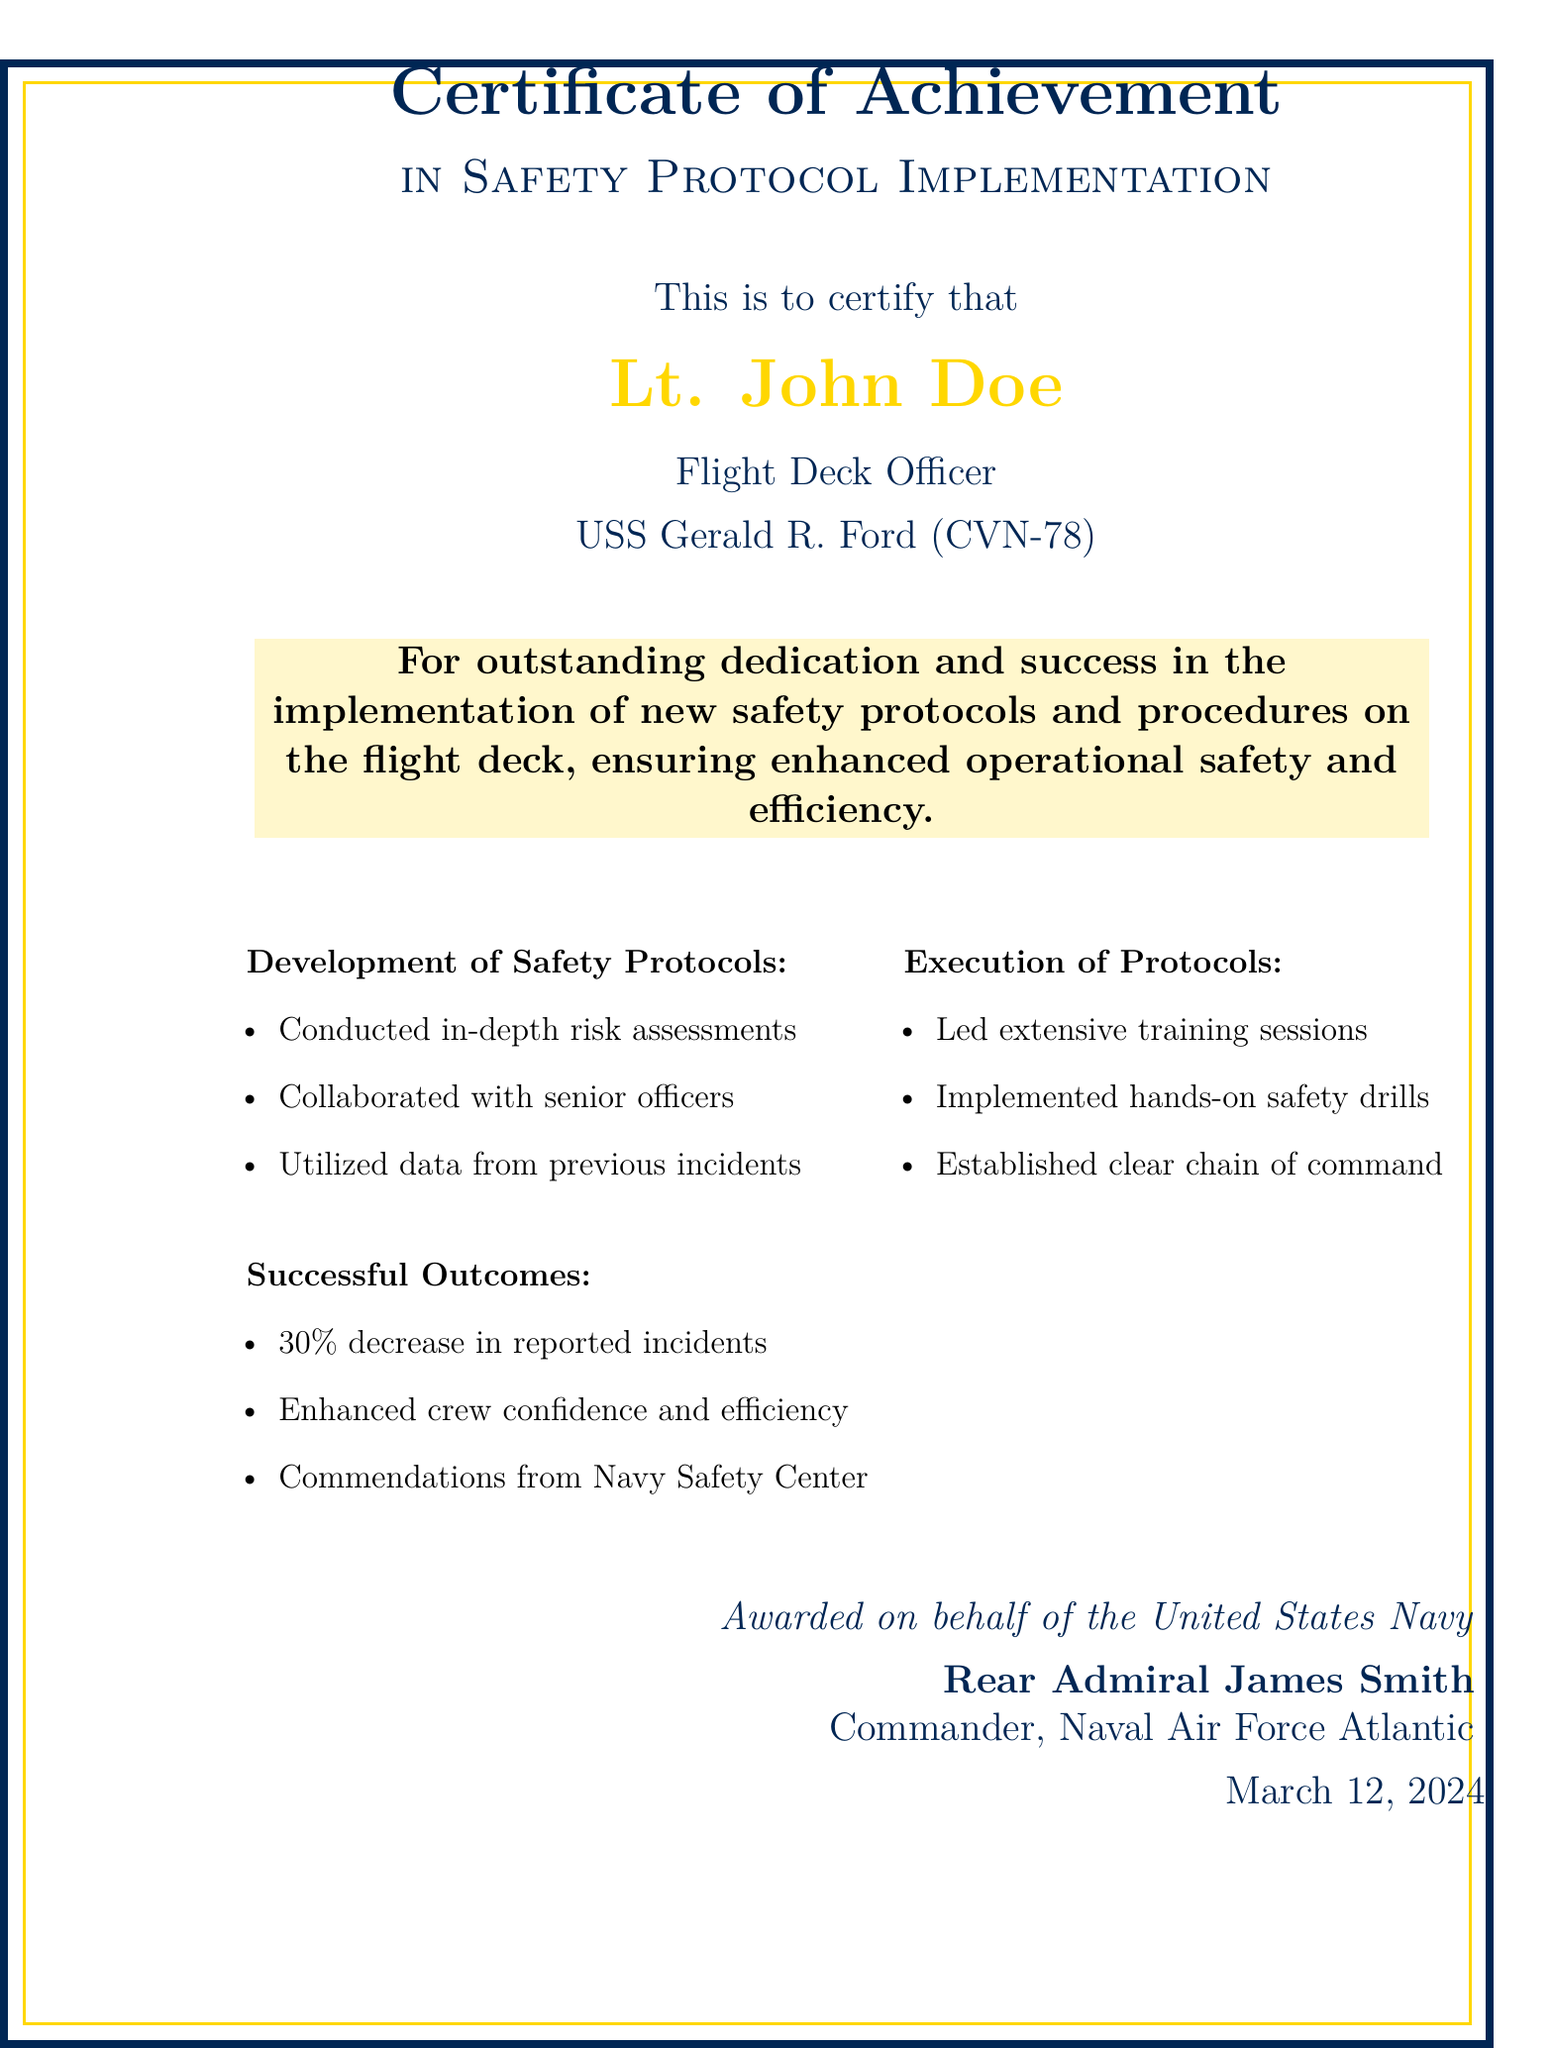What is the title of the certificate? The title of the certificate is shown prominently at the top of the document.
Answer: Certificate of Achievement Who is the recipient of the certificate? The recipient's name is displayed in a highlighted format.
Answer: Lt. John Doe What position does the recipient hold? The position is mentioned below the recipient's name.
Answer: Flight Deck Officer Which aircraft carrier is associated with the certificate? The aircraft carrier's name is included in the document.
Answer: USS Gerald R. Ford (CVN-78) What was the percentage decrease in reported incidents? The outcome section explicitly states this figure.
Answer: 30% Who awarded the certificate? The name of the individual who awarded the certificate is detailed in the sign-off section.
Answer: Rear Admiral James Smith When was the certificate awarded? The award date is noted in the lower section of the document.
Answer: March 12, 2024 What was one of the successful outcomes of the implemented protocols? Successful outcomes are listed in a bullet point format.
Answer: Enhanced crew confidence and efficiency What type of training sessions were led as part of protocol execution? The execution section specifies the nature of the sessions.
Answer: Extensive training sessions 